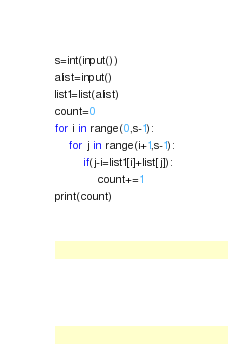Convert code to text. <code><loc_0><loc_0><loc_500><loc_500><_Python_>s=int(input())
alist=input()
list1=list(alist)
count=0
for i in range(0,s-1):
	for j in range(i+1,s-1):
    	if(j-i=list1[i]+list[j]):
        	count+=1
print(count)            
            
      
      
	  
  </code> 